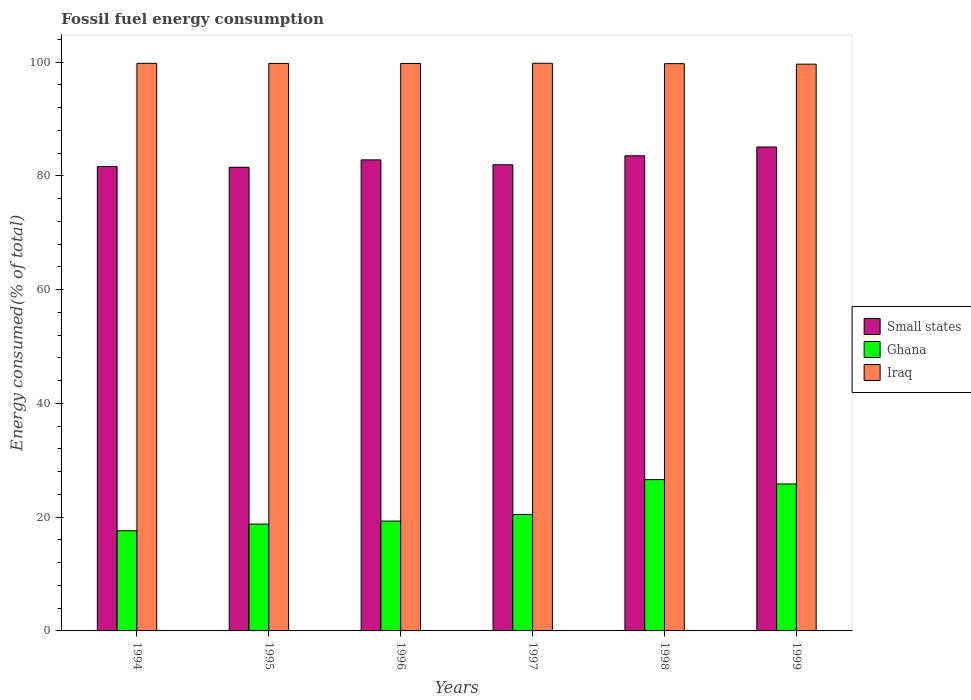How many different coloured bars are there?
Your response must be concise. 3. Are the number of bars on each tick of the X-axis equal?
Your answer should be compact. Yes. How many bars are there on the 6th tick from the left?
Make the answer very short. 3. What is the label of the 3rd group of bars from the left?
Provide a short and direct response. 1996. What is the percentage of energy consumed in Iraq in 1995?
Your answer should be compact. 99.78. Across all years, what is the maximum percentage of energy consumed in Small states?
Offer a terse response. 85.08. Across all years, what is the minimum percentage of energy consumed in Small states?
Your response must be concise. 81.52. In which year was the percentage of energy consumed in Iraq minimum?
Offer a very short reply. 1999. What is the total percentage of energy consumed in Ghana in the graph?
Give a very brief answer. 128.61. What is the difference between the percentage of energy consumed in Ghana in 1997 and that in 1998?
Your answer should be very brief. -6.12. What is the difference between the percentage of energy consumed in Ghana in 1996 and the percentage of energy consumed in Small states in 1994?
Make the answer very short. -62.33. What is the average percentage of energy consumed in Ghana per year?
Your response must be concise. 21.44. In the year 1997, what is the difference between the percentage of energy consumed in Small states and percentage of energy consumed in Iraq?
Provide a short and direct response. -17.85. What is the ratio of the percentage of energy consumed in Ghana in 1996 to that in 1997?
Offer a very short reply. 0.94. What is the difference between the highest and the second highest percentage of energy consumed in Small states?
Your answer should be very brief. 1.55. What is the difference between the highest and the lowest percentage of energy consumed in Small states?
Your answer should be compact. 3.56. In how many years, is the percentage of energy consumed in Iraq greater than the average percentage of energy consumed in Iraq taken over all years?
Provide a short and direct response. 4. What does the 1st bar from the left in 1997 represents?
Your answer should be very brief. Small states. What does the 3rd bar from the right in 1999 represents?
Offer a terse response. Small states. How many bars are there?
Provide a short and direct response. 18. Are all the bars in the graph horizontal?
Make the answer very short. No. How many years are there in the graph?
Your answer should be very brief. 6. What is the difference between two consecutive major ticks on the Y-axis?
Offer a terse response. 20. Does the graph contain any zero values?
Make the answer very short. No. What is the title of the graph?
Keep it short and to the point. Fossil fuel energy consumption. What is the label or title of the Y-axis?
Give a very brief answer. Energy consumed(% of total). What is the Energy consumed(% of total) in Small states in 1994?
Offer a very short reply. 81.65. What is the Energy consumed(% of total) in Ghana in 1994?
Your answer should be very brief. 17.61. What is the Energy consumed(% of total) in Iraq in 1994?
Give a very brief answer. 99.79. What is the Energy consumed(% of total) in Small states in 1995?
Your answer should be compact. 81.52. What is the Energy consumed(% of total) of Ghana in 1995?
Offer a very short reply. 18.79. What is the Energy consumed(% of total) in Iraq in 1995?
Offer a terse response. 99.78. What is the Energy consumed(% of total) in Small states in 1996?
Your answer should be compact. 82.82. What is the Energy consumed(% of total) in Ghana in 1996?
Your answer should be compact. 19.31. What is the Energy consumed(% of total) of Iraq in 1996?
Your answer should be compact. 99.78. What is the Energy consumed(% of total) of Small states in 1997?
Provide a succinct answer. 81.96. What is the Energy consumed(% of total) of Ghana in 1997?
Give a very brief answer. 20.47. What is the Energy consumed(% of total) in Iraq in 1997?
Your answer should be very brief. 99.8. What is the Energy consumed(% of total) of Small states in 1998?
Offer a very short reply. 83.54. What is the Energy consumed(% of total) in Ghana in 1998?
Keep it short and to the point. 26.59. What is the Energy consumed(% of total) in Iraq in 1998?
Provide a succinct answer. 99.73. What is the Energy consumed(% of total) in Small states in 1999?
Your answer should be compact. 85.08. What is the Energy consumed(% of total) in Ghana in 1999?
Your answer should be compact. 25.84. What is the Energy consumed(% of total) of Iraq in 1999?
Offer a terse response. 99.65. Across all years, what is the maximum Energy consumed(% of total) in Small states?
Your answer should be compact. 85.08. Across all years, what is the maximum Energy consumed(% of total) in Ghana?
Your response must be concise. 26.59. Across all years, what is the maximum Energy consumed(% of total) in Iraq?
Provide a succinct answer. 99.8. Across all years, what is the minimum Energy consumed(% of total) of Small states?
Your response must be concise. 81.52. Across all years, what is the minimum Energy consumed(% of total) in Ghana?
Your answer should be compact. 17.61. Across all years, what is the minimum Energy consumed(% of total) of Iraq?
Provide a short and direct response. 99.65. What is the total Energy consumed(% of total) of Small states in the graph?
Make the answer very short. 496.57. What is the total Energy consumed(% of total) in Ghana in the graph?
Provide a succinct answer. 128.61. What is the total Energy consumed(% of total) of Iraq in the graph?
Offer a terse response. 598.53. What is the difference between the Energy consumed(% of total) of Small states in 1994 and that in 1995?
Your answer should be compact. 0.12. What is the difference between the Energy consumed(% of total) of Ghana in 1994 and that in 1995?
Offer a very short reply. -1.17. What is the difference between the Energy consumed(% of total) in Iraq in 1994 and that in 1995?
Ensure brevity in your answer.  0.01. What is the difference between the Energy consumed(% of total) in Small states in 1994 and that in 1996?
Keep it short and to the point. -1.17. What is the difference between the Energy consumed(% of total) of Ghana in 1994 and that in 1996?
Provide a succinct answer. -1.7. What is the difference between the Energy consumed(% of total) in Iraq in 1994 and that in 1996?
Provide a short and direct response. 0.02. What is the difference between the Energy consumed(% of total) of Small states in 1994 and that in 1997?
Keep it short and to the point. -0.31. What is the difference between the Energy consumed(% of total) in Ghana in 1994 and that in 1997?
Make the answer very short. -2.86. What is the difference between the Energy consumed(% of total) in Iraq in 1994 and that in 1997?
Give a very brief answer. -0.01. What is the difference between the Energy consumed(% of total) in Small states in 1994 and that in 1998?
Keep it short and to the point. -1.89. What is the difference between the Energy consumed(% of total) in Ghana in 1994 and that in 1998?
Provide a succinct answer. -8.98. What is the difference between the Energy consumed(% of total) of Iraq in 1994 and that in 1998?
Make the answer very short. 0.06. What is the difference between the Energy consumed(% of total) of Small states in 1994 and that in 1999?
Give a very brief answer. -3.44. What is the difference between the Energy consumed(% of total) of Ghana in 1994 and that in 1999?
Offer a very short reply. -8.23. What is the difference between the Energy consumed(% of total) of Iraq in 1994 and that in 1999?
Your answer should be compact. 0.14. What is the difference between the Energy consumed(% of total) in Small states in 1995 and that in 1996?
Your response must be concise. -1.3. What is the difference between the Energy consumed(% of total) of Ghana in 1995 and that in 1996?
Keep it short and to the point. -0.53. What is the difference between the Energy consumed(% of total) in Iraq in 1995 and that in 1996?
Provide a short and direct response. 0.01. What is the difference between the Energy consumed(% of total) of Small states in 1995 and that in 1997?
Make the answer very short. -0.44. What is the difference between the Energy consumed(% of total) of Ghana in 1995 and that in 1997?
Ensure brevity in your answer.  -1.68. What is the difference between the Energy consumed(% of total) in Iraq in 1995 and that in 1997?
Make the answer very short. -0.02. What is the difference between the Energy consumed(% of total) in Small states in 1995 and that in 1998?
Make the answer very short. -2.01. What is the difference between the Energy consumed(% of total) in Ghana in 1995 and that in 1998?
Give a very brief answer. -7.81. What is the difference between the Energy consumed(% of total) in Iraq in 1995 and that in 1998?
Your answer should be compact. 0.05. What is the difference between the Energy consumed(% of total) in Small states in 1995 and that in 1999?
Keep it short and to the point. -3.56. What is the difference between the Energy consumed(% of total) of Ghana in 1995 and that in 1999?
Keep it short and to the point. -7.06. What is the difference between the Energy consumed(% of total) of Iraq in 1995 and that in 1999?
Give a very brief answer. 0.13. What is the difference between the Energy consumed(% of total) in Small states in 1996 and that in 1997?
Offer a terse response. 0.86. What is the difference between the Energy consumed(% of total) in Ghana in 1996 and that in 1997?
Ensure brevity in your answer.  -1.16. What is the difference between the Energy consumed(% of total) in Iraq in 1996 and that in 1997?
Give a very brief answer. -0.03. What is the difference between the Energy consumed(% of total) in Small states in 1996 and that in 1998?
Provide a short and direct response. -0.72. What is the difference between the Energy consumed(% of total) in Ghana in 1996 and that in 1998?
Make the answer very short. -7.28. What is the difference between the Energy consumed(% of total) of Iraq in 1996 and that in 1998?
Ensure brevity in your answer.  0.04. What is the difference between the Energy consumed(% of total) of Small states in 1996 and that in 1999?
Ensure brevity in your answer.  -2.26. What is the difference between the Energy consumed(% of total) in Ghana in 1996 and that in 1999?
Make the answer very short. -6.53. What is the difference between the Energy consumed(% of total) in Iraq in 1996 and that in 1999?
Give a very brief answer. 0.13. What is the difference between the Energy consumed(% of total) of Small states in 1997 and that in 1998?
Provide a short and direct response. -1.58. What is the difference between the Energy consumed(% of total) in Ghana in 1997 and that in 1998?
Make the answer very short. -6.12. What is the difference between the Energy consumed(% of total) of Iraq in 1997 and that in 1998?
Offer a terse response. 0.07. What is the difference between the Energy consumed(% of total) of Small states in 1997 and that in 1999?
Keep it short and to the point. -3.12. What is the difference between the Energy consumed(% of total) of Ghana in 1997 and that in 1999?
Provide a short and direct response. -5.37. What is the difference between the Energy consumed(% of total) of Iraq in 1997 and that in 1999?
Make the answer very short. 0.16. What is the difference between the Energy consumed(% of total) in Small states in 1998 and that in 1999?
Provide a succinct answer. -1.55. What is the difference between the Energy consumed(% of total) in Ghana in 1998 and that in 1999?
Give a very brief answer. 0.75. What is the difference between the Energy consumed(% of total) of Iraq in 1998 and that in 1999?
Ensure brevity in your answer.  0.09. What is the difference between the Energy consumed(% of total) in Small states in 1994 and the Energy consumed(% of total) in Ghana in 1995?
Make the answer very short. 62.86. What is the difference between the Energy consumed(% of total) in Small states in 1994 and the Energy consumed(% of total) in Iraq in 1995?
Offer a terse response. -18.14. What is the difference between the Energy consumed(% of total) in Ghana in 1994 and the Energy consumed(% of total) in Iraq in 1995?
Your answer should be compact. -82.17. What is the difference between the Energy consumed(% of total) in Small states in 1994 and the Energy consumed(% of total) in Ghana in 1996?
Provide a short and direct response. 62.33. What is the difference between the Energy consumed(% of total) of Small states in 1994 and the Energy consumed(% of total) of Iraq in 1996?
Offer a very short reply. -18.13. What is the difference between the Energy consumed(% of total) of Ghana in 1994 and the Energy consumed(% of total) of Iraq in 1996?
Offer a terse response. -82.16. What is the difference between the Energy consumed(% of total) of Small states in 1994 and the Energy consumed(% of total) of Ghana in 1997?
Your answer should be compact. 61.18. What is the difference between the Energy consumed(% of total) in Small states in 1994 and the Energy consumed(% of total) in Iraq in 1997?
Keep it short and to the point. -18.16. What is the difference between the Energy consumed(% of total) of Ghana in 1994 and the Energy consumed(% of total) of Iraq in 1997?
Ensure brevity in your answer.  -82.19. What is the difference between the Energy consumed(% of total) of Small states in 1994 and the Energy consumed(% of total) of Ghana in 1998?
Your answer should be very brief. 55.05. What is the difference between the Energy consumed(% of total) in Small states in 1994 and the Energy consumed(% of total) in Iraq in 1998?
Give a very brief answer. -18.09. What is the difference between the Energy consumed(% of total) of Ghana in 1994 and the Energy consumed(% of total) of Iraq in 1998?
Offer a very short reply. -82.12. What is the difference between the Energy consumed(% of total) in Small states in 1994 and the Energy consumed(% of total) in Ghana in 1999?
Provide a short and direct response. 55.8. What is the difference between the Energy consumed(% of total) in Small states in 1994 and the Energy consumed(% of total) in Iraq in 1999?
Offer a terse response. -18. What is the difference between the Energy consumed(% of total) of Ghana in 1994 and the Energy consumed(% of total) of Iraq in 1999?
Make the answer very short. -82.04. What is the difference between the Energy consumed(% of total) of Small states in 1995 and the Energy consumed(% of total) of Ghana in 1996?
Your answer should be very brief. 62.21. What is the difference between the Energy consumed(% of total) in Small states in 1995 and the Energy consumed(% of total) in Iraq in 1996?
Your answer should be very brief. -18.25. What is the difference between the Energy consumed(% of total) in Ghana in 1995 and the Energy consumed(% of total) in Iraq in 1996?
Offer a terse response. -80.99. What is the difference between the Energy consumed(% of total) in Small states in 1995 and the Energy consumed(% of total) in Ghana in 1997?
Offer a very short reply. 61.05. What is the difference between the Energy consumed(% of total) in Small states in 1995 and the Energy consumed(% of total) in Iraq in 1997?
Make the answer very short. -18.28. What is the difference between the Energy consumed(% of total) in Ghana in 1995 and the Energy consumed(% of total) in Iraq in 1997?
Your answer should be very brief. -81.02. What is the difference between the Energy consumed(% of total) of Small states in 1995 and the Energy consumed(% of total) of Ghana in 1998?
Your answer should be very brief. 54.93. What is the difference between the Energy consumed(% of total) in Small states in 1995 and the Energy consumed(% of total) in Iraq in 1998?
Offer a terse response. -18.21. What is the difference between the Energy consumed(% of total) in Ghana in 1995 and the Energy consumed(% of total) in Iraq in 1998?
Give a very brief answer. -80.95. What is the difference between the Energy consumed(% of total) of Small states in 1995 and the Energy consumed(% of total) of Ghana in 1999?
Keep it short and to the point. 55.68. What is the difference between the Energy consumed(% of total) of Small states in 1995 and the Energy consumed(% of total) of Iraq in 1999?
Ensure brevity in your answer.  -18.12. What is the difference between the Energy consumed(% of total) of Ghana in 1995 and the Energy consumed(% of total) of Iraq in 1999?
Offer a very short reply. -80.86. What is the difference between the Energy consumed(% of total) of Small states in 1996 and the Energy consumed(% of total) of Ghana in 1997?
Ensure brevity in your answer.  62.35. What is the difference between the Energy consumed(% of total) in Small states in 1996 and the Energy consumed(% of total) in Iraq in 1997?
Your response must be concise. -16.99. What is the difference between the Energy consumed(% of total) of Ghana in 1996 and the Energy consumed(% of total) of Iraq in 1997?
Ensure brevity in your answer.  -80.49. What is the difference between the Energy consumed(% of total) of Small states in 1996 and the Energy consumed(% of total) of Ghana in 1998?
Offer a very short reply. 56.23. What is the difference between the Energy consumed(% of total) of Small states in 1996 and the Energy consumed(% of total) of Iraq in 1998?
Your answer should be very brief. -16.91. What is the difference between the Energy consumed(% of total) in Ghana in 1996 and the Energy consumed(% of total) in Iraq in 1998?
Give a very brief answer. -80.42. What is the difference between the Energy consumed(% of total) in Small states in 1996 and the Energy consumed(% of total) in Ghana in 1999?
Offer a very short reply. 56.98. What is the difference between the Energy consumed(% of total) of Small states in 1996 and the Energy consumed(% of total) of Iraq in 1999?
Your response must be concise. -16.83. What is the difference between the Energy consumed(% of total) of Ghana in 1996 and the Energy consumed(% of total) of Iraq in 1999?
Offer a terse response. -80.34. What is the difference between the Energy consumed(% of total) of Small states in 1997 and the Energy consumed(% of total) of Ghana in 1998?
Provide a short and direct response. 55.37. What is the difference between the Energy consumed(% of total) of Small states in 1997 and the Energy consumed(% of total) of Iraq in 1998?
Offer a terse response. -17.77. What is the difference between the Energy consumed(% of total) in Ghana in 1997 and the Energy consumed(% of total) in Iraq in 1998?
Keep it short and to the point. -79.26. What is the difference between the Energy consumed(% of total) of Small states in 1997 and the Energy consumed(% of total) of Ghana in 1999?
Your response must be concise. 56.12. What is the difference between the Energy consumed(% of total) of Small states in 1997 and the Energy consumed(% of total) of Iraq in 1999?
Your response must be concise. -17.69. What is the difference between the Energy consumed(% of total) in Ghana in 1997 and the Energy consumed(% of total) in Iraq in 1999?
Make the answer very short. -79.18. What is the difference between the Energy consumed(% of total) in Small states in 1998 and the Energy consumed(% of total) in Ghana in 1999?
Offer a terse response. 57.69. What is the difference between the Energy consumed(% of total) of Small states in 1998 and the Energy consumed(% of total) of Iraq in 1999?
Ensure brevity in your answer.  -16.11. What is the difference between the Energy consumed(% of total) in Ghana in 1998 and the Energy consumed(% of total) in Iraq in 1999?
Keep it short and to the point. -73.05. What is the average Energy consumed(% of total) in Small states per year?
Make the answer very short. 82.76. What is the average Energy consumed(% of total) in Ghana per year?
Make the answer very short. 21.44. What is the average Energy consumed(% of total) of Iraq per year?
Give a very brief answer. 99.76. In the year 1994, what is the difference between the Energy consumed(% of total) of Small states and Energy consumed(% of total) of Ghana?
Your answer should be very brief. 64.03. In the year 1994, what is the difference between the Energy consumed(% of total) in Small states and Energy consumed(% of total) in Iraq?
Offer a very short reply. -18.14. In the year 1994, what is the difference between the Energy consumed(% of total) of Ghana and Energy consumed(% of total) of Iraq?
Give a very brief answer. -82.18. In the year 1995, what is the difference between the Energy consumed(% of total) of Small states and Energy consumed(% of total) of Ghana?
Your answer should be very brief. 62.74. In the year 1995, what is the difference between the Energy consumed(% of total) in Small states and Energy consumed(% of total) in Iraq?
Give a very brief answer. -18.26. In the year 1995, what is the difference between the Energy consumed(% of total) of Ghana and Energy consumed(% of total) of Iraq?
Your answer should be very brief. -81. In the year 1996, what is the difference between the Energy consumed(% of total) in Small states and Energy consumed(% of total) in Ghana?
Your response must be concise. 63.51. In the year 1996, what is the difference between the Energy consumed(% of total) of Small states and Energy consumed(% of total) of Iraq?
Offer a very short reply. -16.96. In the year 1996, what is the difference between the Energy consumed(% of total) of Ghana and Energy consumed(% of total) of Iraq?
Give a very brief answer. -80.46. In the year 1997, what is the difference between the Energy consumed(% of total) in Small states and Energy consumed(% of total) in Ghana?
Your answer should be compact. 61.49. In the year 1997, what is the difference between the Energy consumed(% of total) in Small states and Energy consumed(% of total) in Iraq?
Your answer should be very brief. -17.85. In the year 1997, what is the difference between the Energy consumed(% of total) of Ghana and Energy consumed(% of total) of Iraq?
Provide a short and direct response. -79.33. In the year 1998, what is the difference between the Energy consumed(% of total) in Small states and Energy consumed(% of total) in Ghana?
Offer a terse response. 56.94. In the year 1998, what is the difference between the Energy consumed(% of total) in Small states and Energy consumed(% of total) in Iraq?
Offer a very short reply. -16.2. In the year 1998, what is the difference between the Energy consumed(% of total) in Ghana and Energy consumed(% of total) in Iraq?
Offer a very short reply. -73.14. In the year 1999, what is the difference between the Energy consumed(% of total) of Small states and Energy consumed(% of total) of Ghana?
Keep it short and to the point. 59.24. In the year 1999, what is the difference between the Energy consumed(% of total) of Small states and Energy consumed(% of total) of Iraq?
Your answer should be compact. -14.56. In the year 1999, what is the difference between the Energy consumed(% of total) of Ghana and Energy consumed(% of total) of Iraq?
Make the answer very short. -73.81. What is the ratio of the Energy consumed(% of total) in Small states in 1994 to that in 1996?
Keep it short and to the point. 0.99. What is the ratio of the Energy consumed(% of total) of Ghana in 1994 to that in 1996?
Offer a very short reply. 0.91. What is the ratio of the Energy consumed(% of total) in Iraq in 1994 to that in 1996?
Your response must be concise. 1. What is the ratio of the Energy consumed(% of total) in Ghana in 1994 to that in 1997?
Provide a succinct answer. 0.86. What is the ratio of the Energy consumed(% of total) of Small states in 1994 to that in 1998?
Keep it short and to the point. 0.98. What is the ratio of the Energy consumed(% of total) in Ghana in 1994 to that in 1998?
Provide a succinct answer. 0.66. What is the ratio of the Energy consumed(% of total) in Small states in 1994 to that in 1999?
Give a very brief answer. 0.96. What is the ratio of the Energy consumed(% of total) in Ghana in 1994 to that in 1999?
Your answer should be compact. 0.68. What is the ratio of the Energy consumed(% of total) of Iraq in 1994 to that in 1999?
Your response must be concise. 1. What is the ratio of the Energy consumed(% of total) of Small states in 1995 to that in 1996?
Your answer should be very brief. 0.98. What is the ratio of the Energy consumed(% of total) of Ghana in 1995 to that in 1996?
Offer a very short reply. 0.97. What is the ratio of the Energy consumed(% of total) of Ghana in 1995 to that in 1997?
Offer a terse response. 0.92. What is the ratio of the Energy consumed(% of total) in Small states in 1995 to that in 1998?
Your answer should be compact. 0.98. What is the ratio of the Energy consumed(% of total) of Ghana in 1995 to that in 1998?
Make the answer very short. 0.71. What is the ratio of the Energy consumed(% of total) of Small states in 1995 to that in 1999?
Your response must be concise. 0.96. What is the ratio of the Energy consumed(% of total) of Ghana in 1995 to that in 1999?
Your answer should be very brief. 0.73. What is the ratio of the Energy consumed(% of total) of Iraq in 1995 to that in 1999?
Your answer should be very brief. 1. What is the ratio of the Energy consumed(% of total) of Small states in 1996 to that in 1997?
Ensure brevity in your answer.  1.01. What is the ratio of the Energy consumed(% of total) of Ghana in 1996 to that in 1997?
Provide a succinct answer. 0.94. What is the ratio of the Energy consumed(% of total) of Iraq in 1996 to that in 1997?
Ensure brevity in your answer.  1. What is the ratio of the Energy consumed(% of total) of Ghana in 1996 to that in 1998?
Your response must be concise. 0.73. What is the ratio of the Energy consumed(% of total) in Iraq in 1996 to that in 1998?
Provide a short and direct response. 1. What is the ratio of the Energy consumed(% of total) of Small states in 1996 to that in 1999?
Provide a short and direct response. 0.97. What is the ratio of the Energy consumed(% of total) in Ghana in 1996 to that in 1999?
Keep it short and to the point. 0.75. What is the ratio of the Energy consumed(% of total) of Iraq in 1996 to that in 1999?
Ensure brevity in your answer.  1. What is the ratio of the Energy consumed(% of total) of Small states in 1997 to that in 1998?
Your answer should be very brief. 0.98. What is the ratio of the Energy consumed(% of total) in Ghana in 1997 to that in 1998?
Offer a very short reply. 0.77. What is the ratio of the Energy consumed(% of total) in Small states in 1997 to that in 1999?
Give a very brief answer. 0.96. What is the ratio of the Energy consumed(% of total) in Ghana in 1997 to that in 1999?
Give a very brief answer. 0.79. What is the ratio of the Energy consumed(% of total) of Small states in 1998 to that in 1999?
Your answer should be very brief. 0.98. What is the ratio of the Energy consumed(% of total) in Ghana in 1998 to that in 1999?
Offer a terse response. 1.03. What is the difference between the highest and the second highest Energy consumed(% of total) in Small states?
Offer a very short reply. 1.55. What is the difference between the highest and the second highest Energy consumed(% of total) of Ghana?
Give a very brief answer. 0.75. What is the difference between the highest and the second highest Energy consumed(% of total) of Iraq?
Offer a terse response. 0.01. What is the difference between the highest and the lowest Energy consumed(% of total) of Small states?
Ensure brevity in your answer.  3.56. What is the difference between the highest and the lowest Energy consumed(% of total) in Ghana?
Make the answer very short. 8.98. What is the difference between the highest and the lowest Energy consumed(% of total) of Iraq?
Keep it short and to the point. 0.16. 